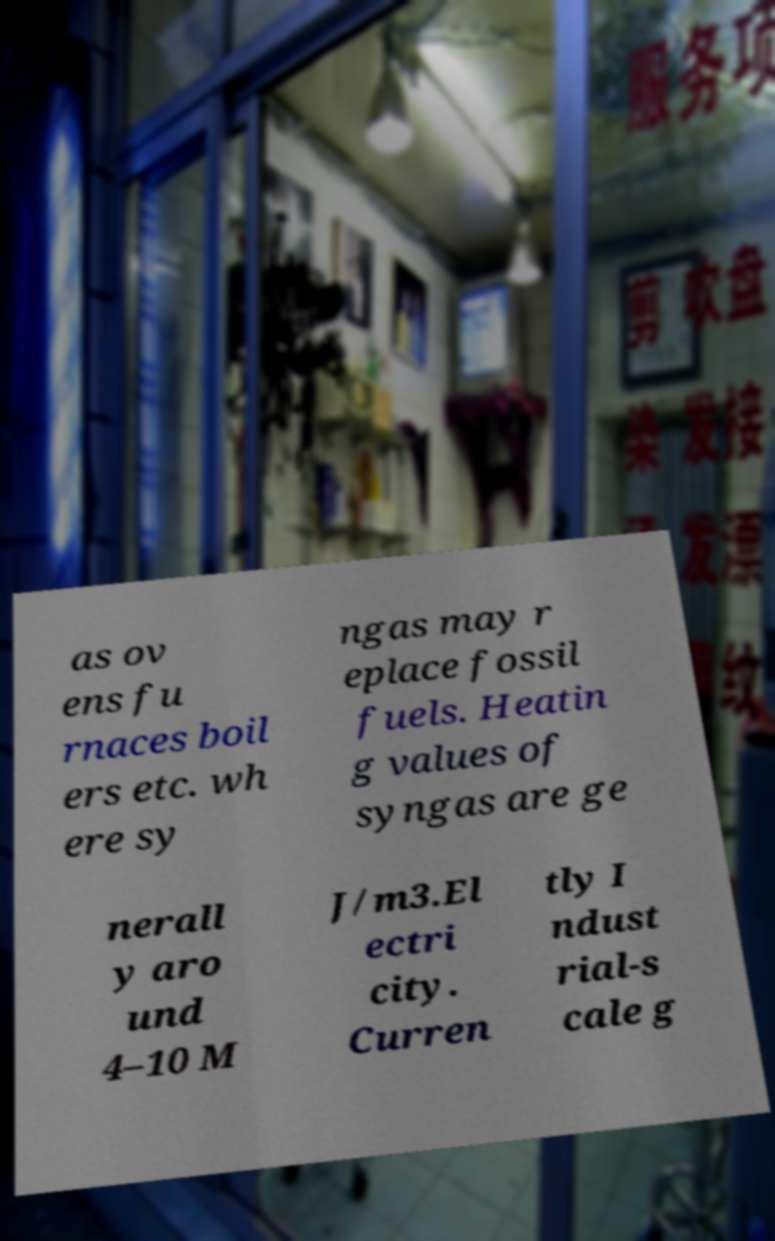What messages or text are displayed in this image? I need them in a readable, typed format. as ov ens fu rnaces boil ers etc. wh ere sy ngas may r eplace fossil fuels. Heatin g values of syngas are ge nerall y aro und 4–10 M J/m3.El ectri city. Curren tly I ndust rial-s cale g 